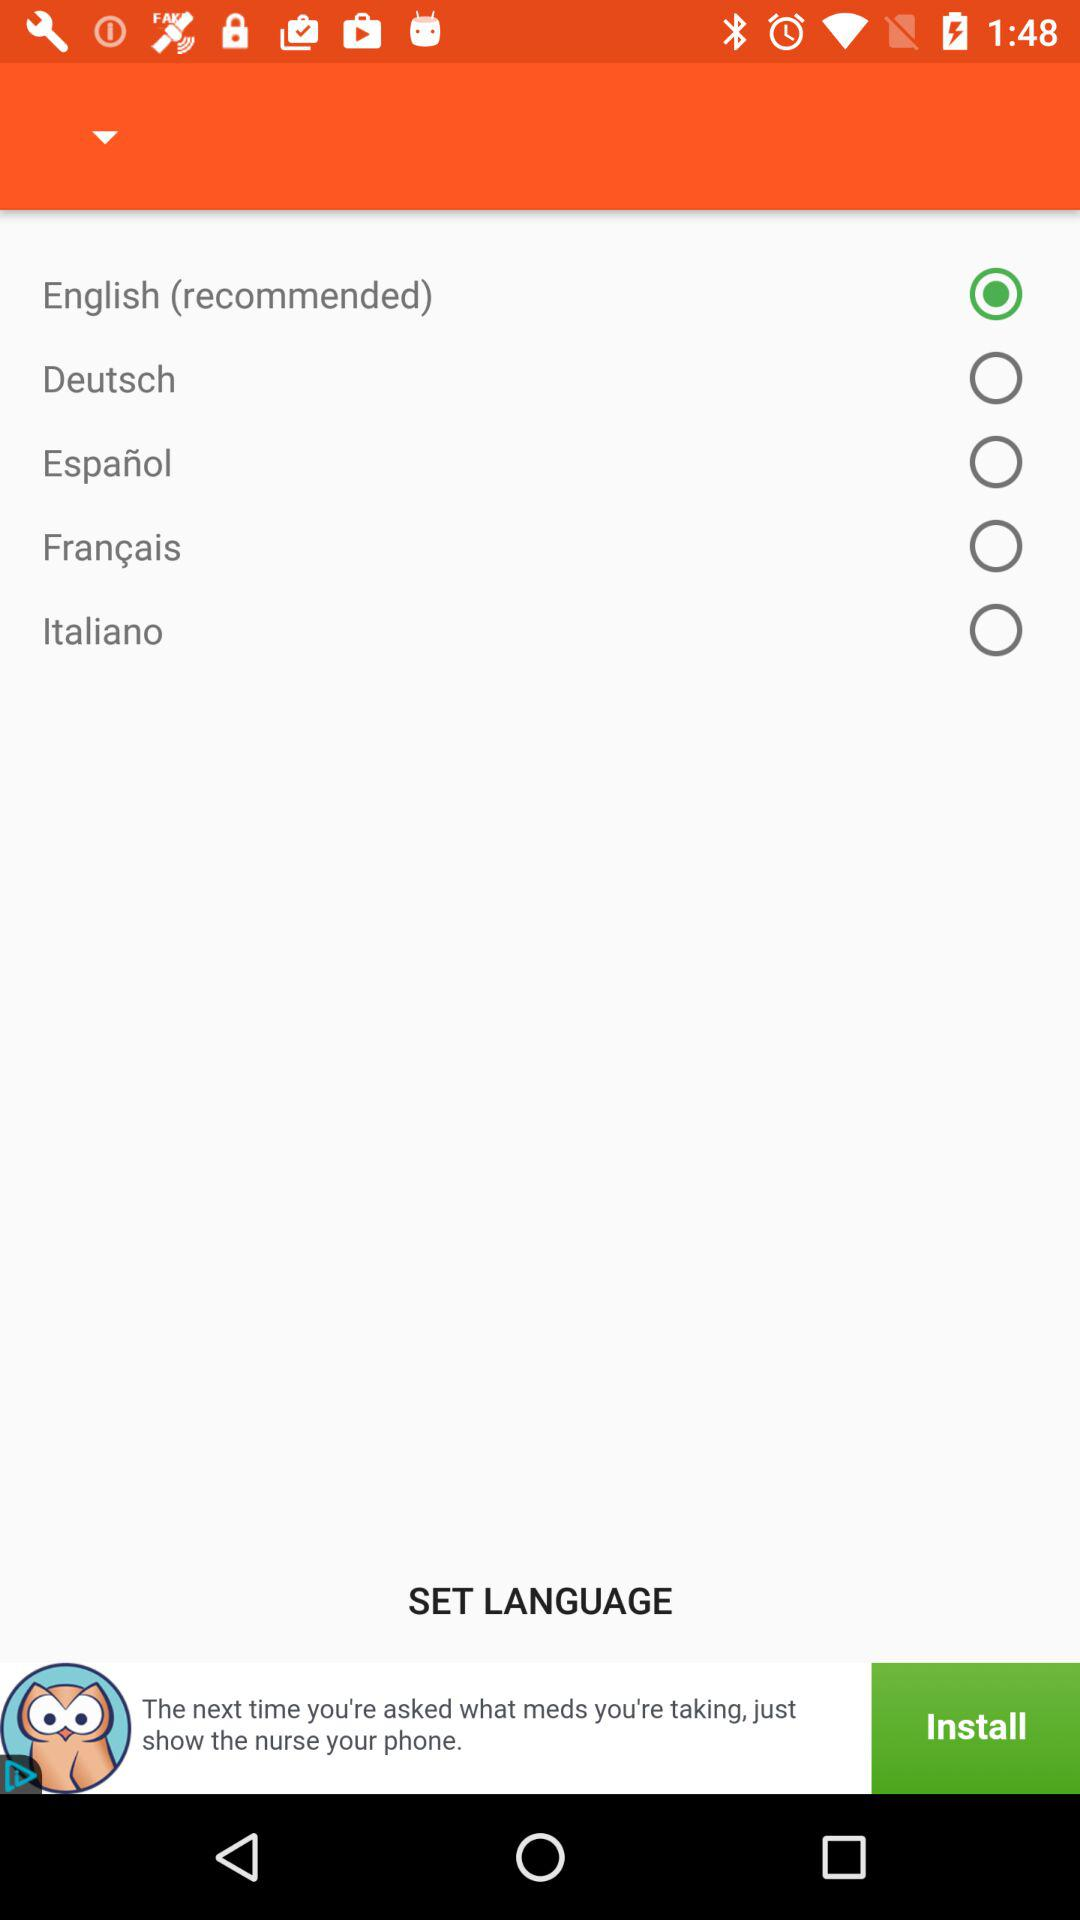How many languages can I choose from?
Answer the question using a single word or phrase. 5 